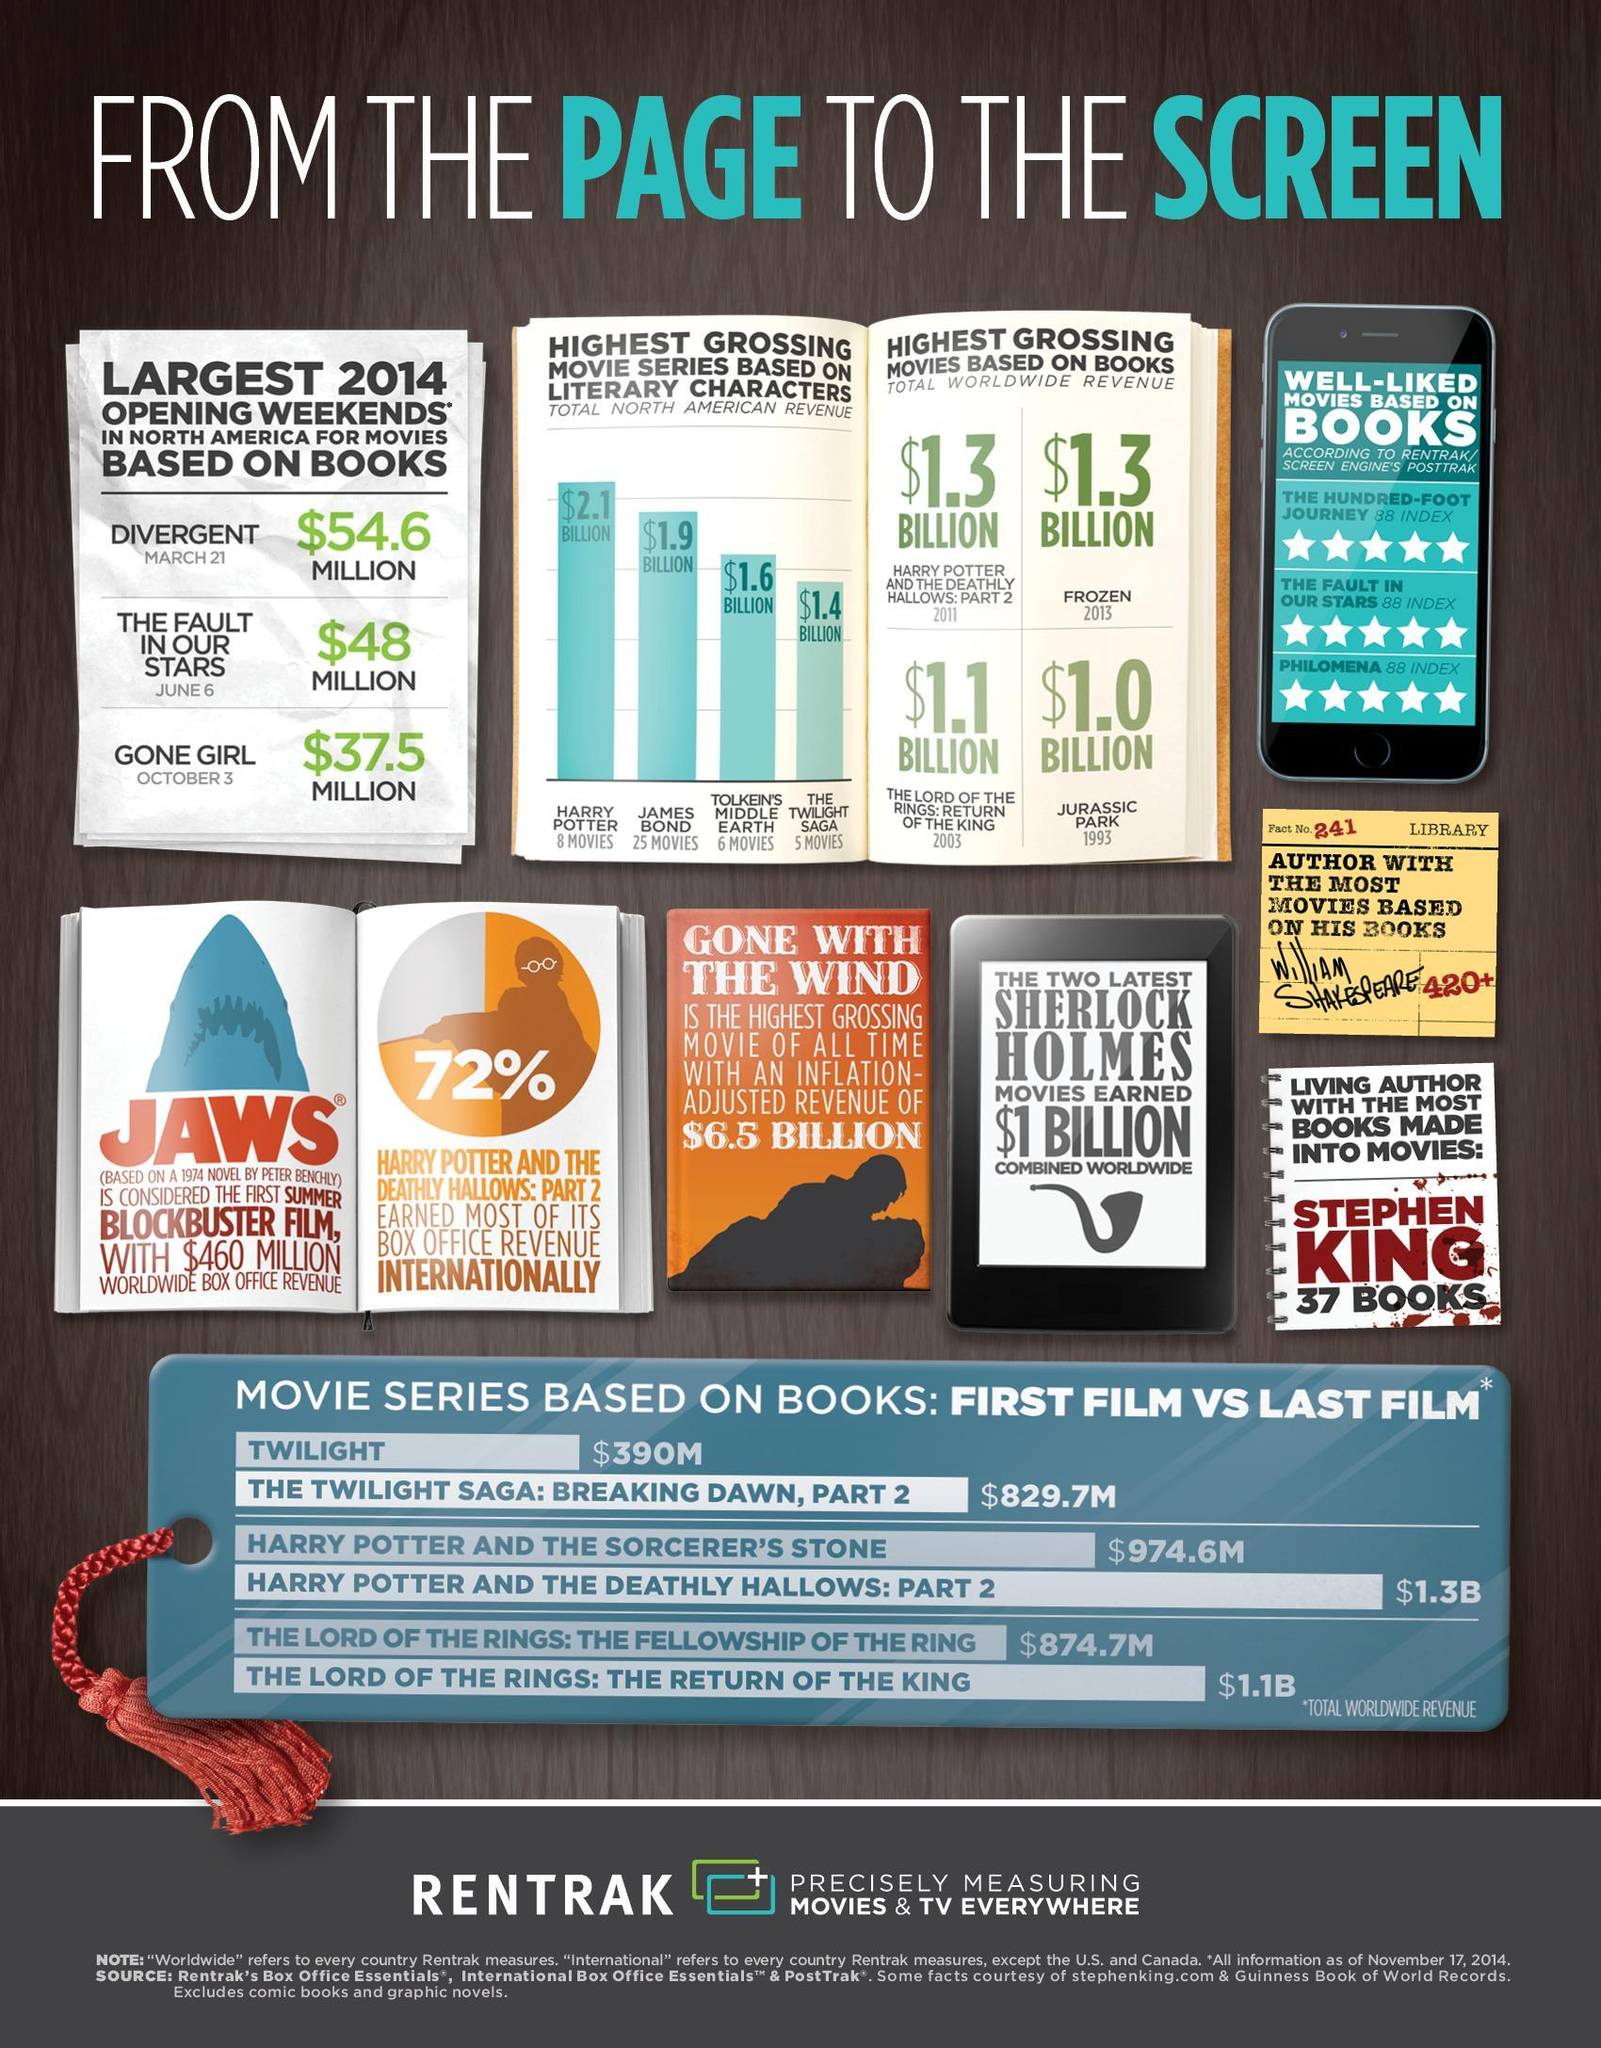Which literary character's movie grossed the highest in North America?
Answer the question with a short phrase. HARRY POTTER When in 2014 was the third highest grossing movie during opening weekend released? OCTOBER 3 By what amount has the movie Breaking Dawn collected more than its first part? $439.7M Which book based movies collected $1.3 BILLION each? HARRY POTTER AND THE DEATHLY HALLOWS:PART 2, FROZEN From the bar graph, which character had the most movies made on him? JAMES BOND Which movie grossed the most during 2014 opening weekends? DIVERGENT Which movie grossed more- James Bond or Tolkien's Middle Earth? JAMES BOND By how much amount has Harry Potter grossed more than The Twilight Saga? $0.7 BILLION How many books have an 88 index as per Rentrak/screen engine's posttrak? 3 Which author has 420+ movies based on his writings? WILLIAM SHAKESPEARE 